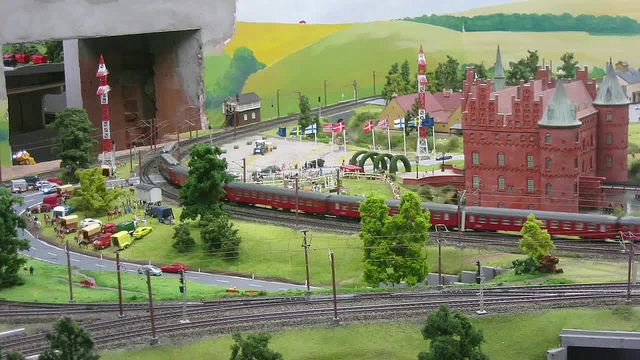How many trains are there? There is one train visible in the image, colored in red. It appears to be a model of a passenger train, situated on well-detailed tracks that mimic those found in real-world train systems. The train and its surrounding miniature setting seem to be part of a model train setup, which is designed to replicate a bustling train station scene. 